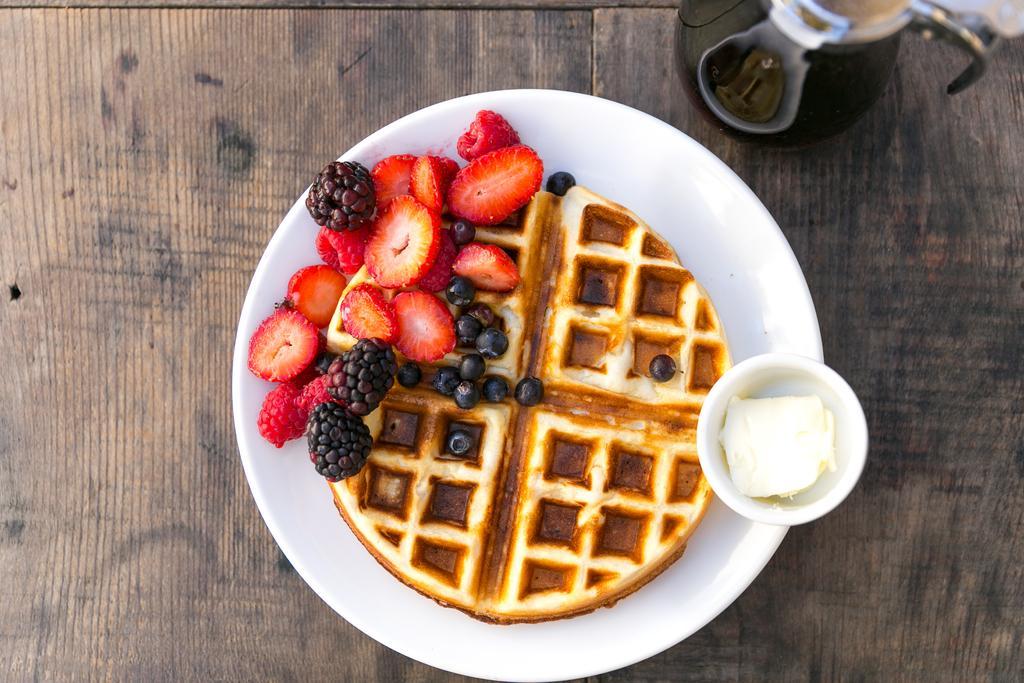Could you give a brief overview of what you see in this image? In this image I can see fruits, bowl and some food items in a plate kept on the table and a kettle. This image is taken may be during a day. 